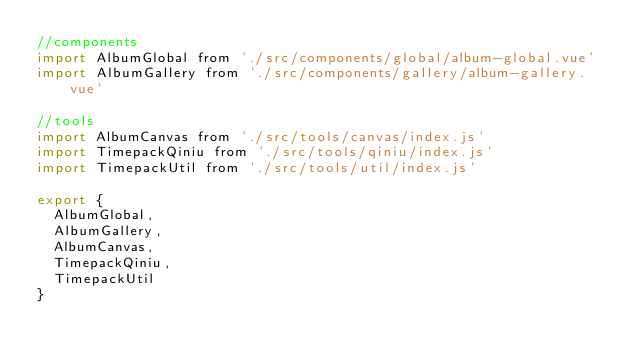Convert code to text. <code><loc_0><loc_0><loc_500><loc_500><_JavaScript_>//components
import AlbumGlobal from './src/components/global/album-global.vue'
import AlbumGallery from './src/components/gallery/album-gallery.vue'

//tools
import AlbumCanvas from './src/tools/canvas/index.js'
import TimepackQiniu from './src/tools/qiniu/index.js'
import TimepackUtil from './src/tools/util/index.js'

export {
  AlbumGlobal,
  AlbumGallery,
  AlbumCanvas,
  TimepackQiniu,
  TimepackUtil
}
</code> 